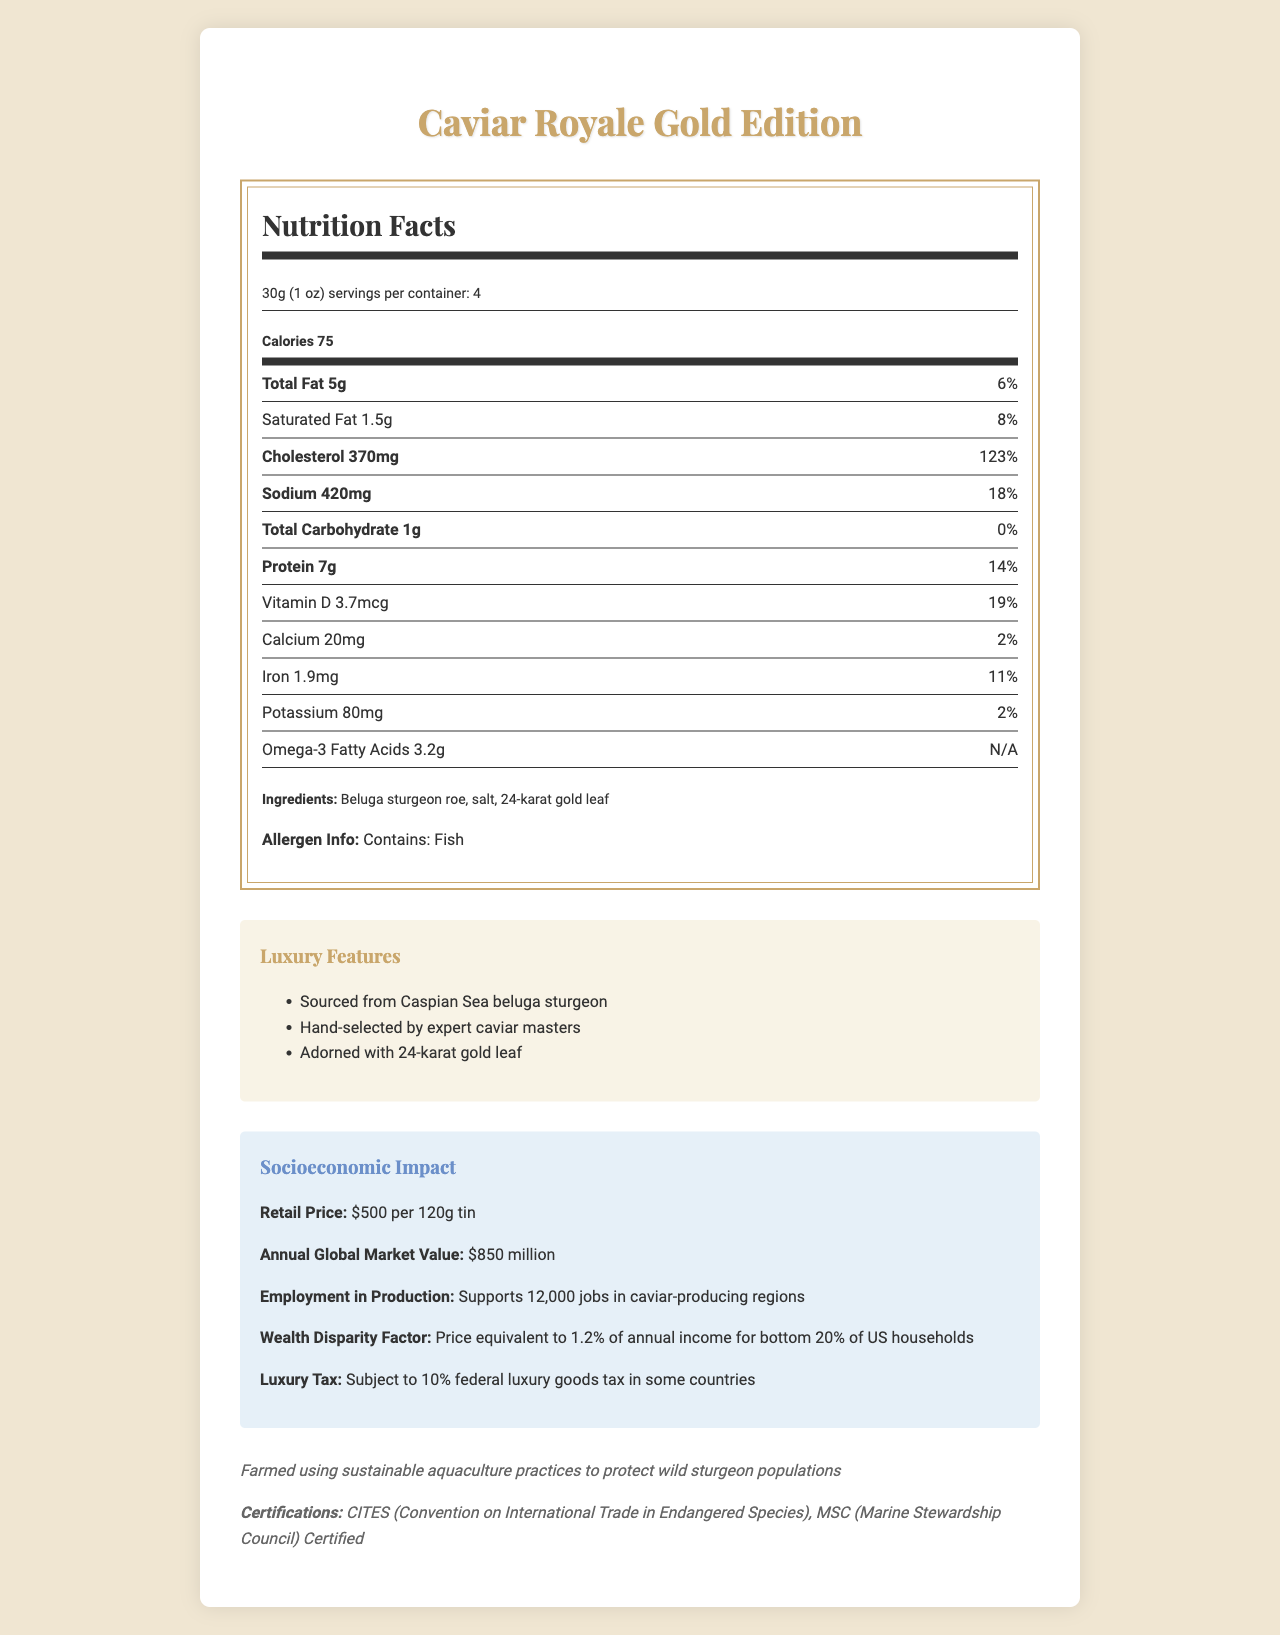what is the product name? The product name is clearly stated at the top of the document.
Answer: Caviar Royale Gold Edition what is the serving size? The serving size is specified under the Nutrition Facts heading.
Answer: 30g (1 oz) how many calories are there per serving? The calorie count per serving is listed under the main information section of the Nutrition Facts.
Answer: 75 calories what are the ingredients? The ingredients are listed near the bottom of the Nutrition Facts panel.
Answer: Beluga sturgeon roe, salt, 24-karat gold leaf what certifications does the product have? The certifications are listed under the sustainability section.
Answer: CITES (Convention on International Trade in Endangered Species), MSC (Marine Stewardship Council) Certified What is the price of the luxury caviar? A. $200 per tin B. $300 per tin C. $500 per tin D. $850 per tin The correct answer, $500 per 120g tin, is mentioned in the socioeconomic impact section.
Answer: C How much protein is in one serving? A. 3g B. 5g C. 7g D. 9g Each serving contains 7g of protein as stated in the Nutrition Facts.
Answer: C Does the product contain any allergens? The allergen information notes that the product contains fish.
Answer: Yes Is this product subject to federal luxury goods tax in some countries? The socioeconomic impact section specifies that the product is subject to a 10% federal luxury goods tax in some countries.
Answer: Yes summarize the entire document The document is divided into different sections that cover nutritional information, luxury features, socioeconomic impact, and sustainability.
Answer: The document provides detailed information on the Caviar Royale Gold Edition, including its Nutrition Facts, luxury features, socioeconomic impact, and sustainability efforts. It lists ingredients, allergens, and certifications, while highlighting the high price and luxury status of the product. How many servings are per container? The number of servings per container is mentioned right after the serving size.
Answer: 4 What is the wealth disparity factor mentioned in the document? This information is provided in the socioeconomic impact section.
Answer: Price equivalent to 1.2% of annual income for bottom 20% of US households What amount of Vitamin D does one serving contain? The amount of Vitamin D per serving is listed in the Nutrition Facts.
Answer: 3.7mcg What type of caviar is used in this product? The specific type of caviar is mentioned in the ingredients and luxury features sections.
Answer: Beluga sturgeon roe Where is the caviar sourced from? The luxury features section specifies that the caviar is sourced from Caspian Sea beluga sturgeon.
Answer: Caspian Sea what is the annual global market value of this product? This is specified in the socioeconomic impact section.
Answer: $850 million How many jobs does the production of caviar support? The employment in production is mentioned in the socioeconomic impact section.
Answer: Supports 12,000 jobs in caviar-producing regions How much saturated fat is in a serving? The saturated fat content is listed in the Nutrition Facts.
Answer: 1.5g what impact does the product have on your daily cholesterol intake? The cholesterol content is very high at 370mg, which is 123% of the daily value according to the Nutrition Facts.
Answer: Significantly high impact (123% of Daily Value) Which aquaculture practice is emphasized in the sustainability note? The sustainability note specifically mentions farmed using sustainable aquaculture practices to protect wild sturgeon populations.
Answer: Sustainable aquaculture what are the luxury features highlighted in the document? The luxury features section lists these elements which underline the product's high-end status.
Answer: Sourced from Caspian Sea beluga sturgeon, hand-selected by expert caviar masters, adorned with 24-karat gold leaf What is the environmental certification provided for this product? The MSC certification is mentioned in the sustainability section along with CITES.
Answer: MSC (Marine Stewardship Council) Certified How does the document illustrate wealth disparity associated with this product? This striking statistic is noted in the socioeconomic impact section, highlighting the disparity.
Answer: The retail price is equivalent to 1.2% of the annual income for the bottom 20% of US households. What is the main drawback of consuming this product based on nutrition facts? The highest daily value percentage listed is for cholesterol, indicating this is a major concern.
Answer: High cholesterol (370mg, 123% of Daily Value) 